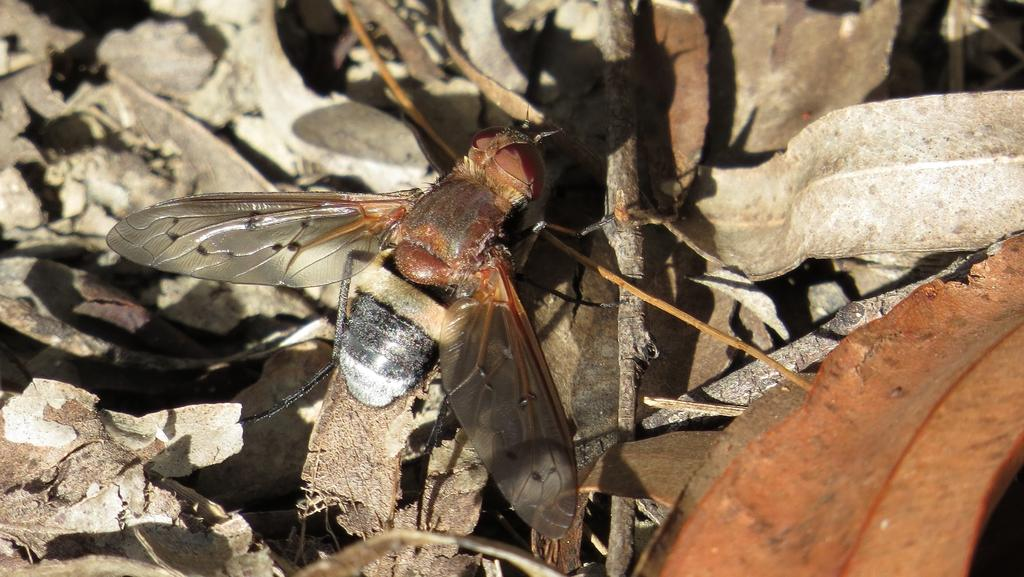What type of vegetation can be seen in the image? There are leaves in the image. What is the main subject in the center of the image? There is an insect in the center of the image. What type of food is the bear eating near the river in the image? There is no bear or river present in the image; it only features leaves and an insect. 